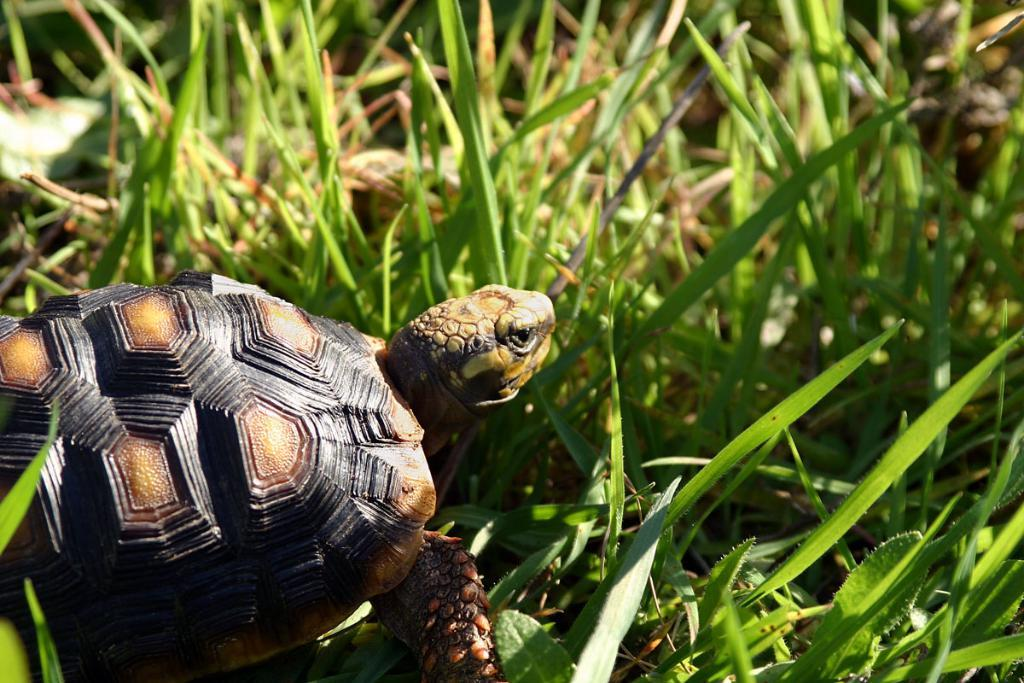What type of animal is in the image? There is a tortoise in the image. Can you describe the coloring of the tortoise? The tortoise has brown and black coloring. What is in front of the tortoise in the image? There is green grass in front of the tortoise. What type of bait is the tortoise using to catch fish in the image? There is no bait or fishing activity depicted in the image; it features a tortoise on green grass. 